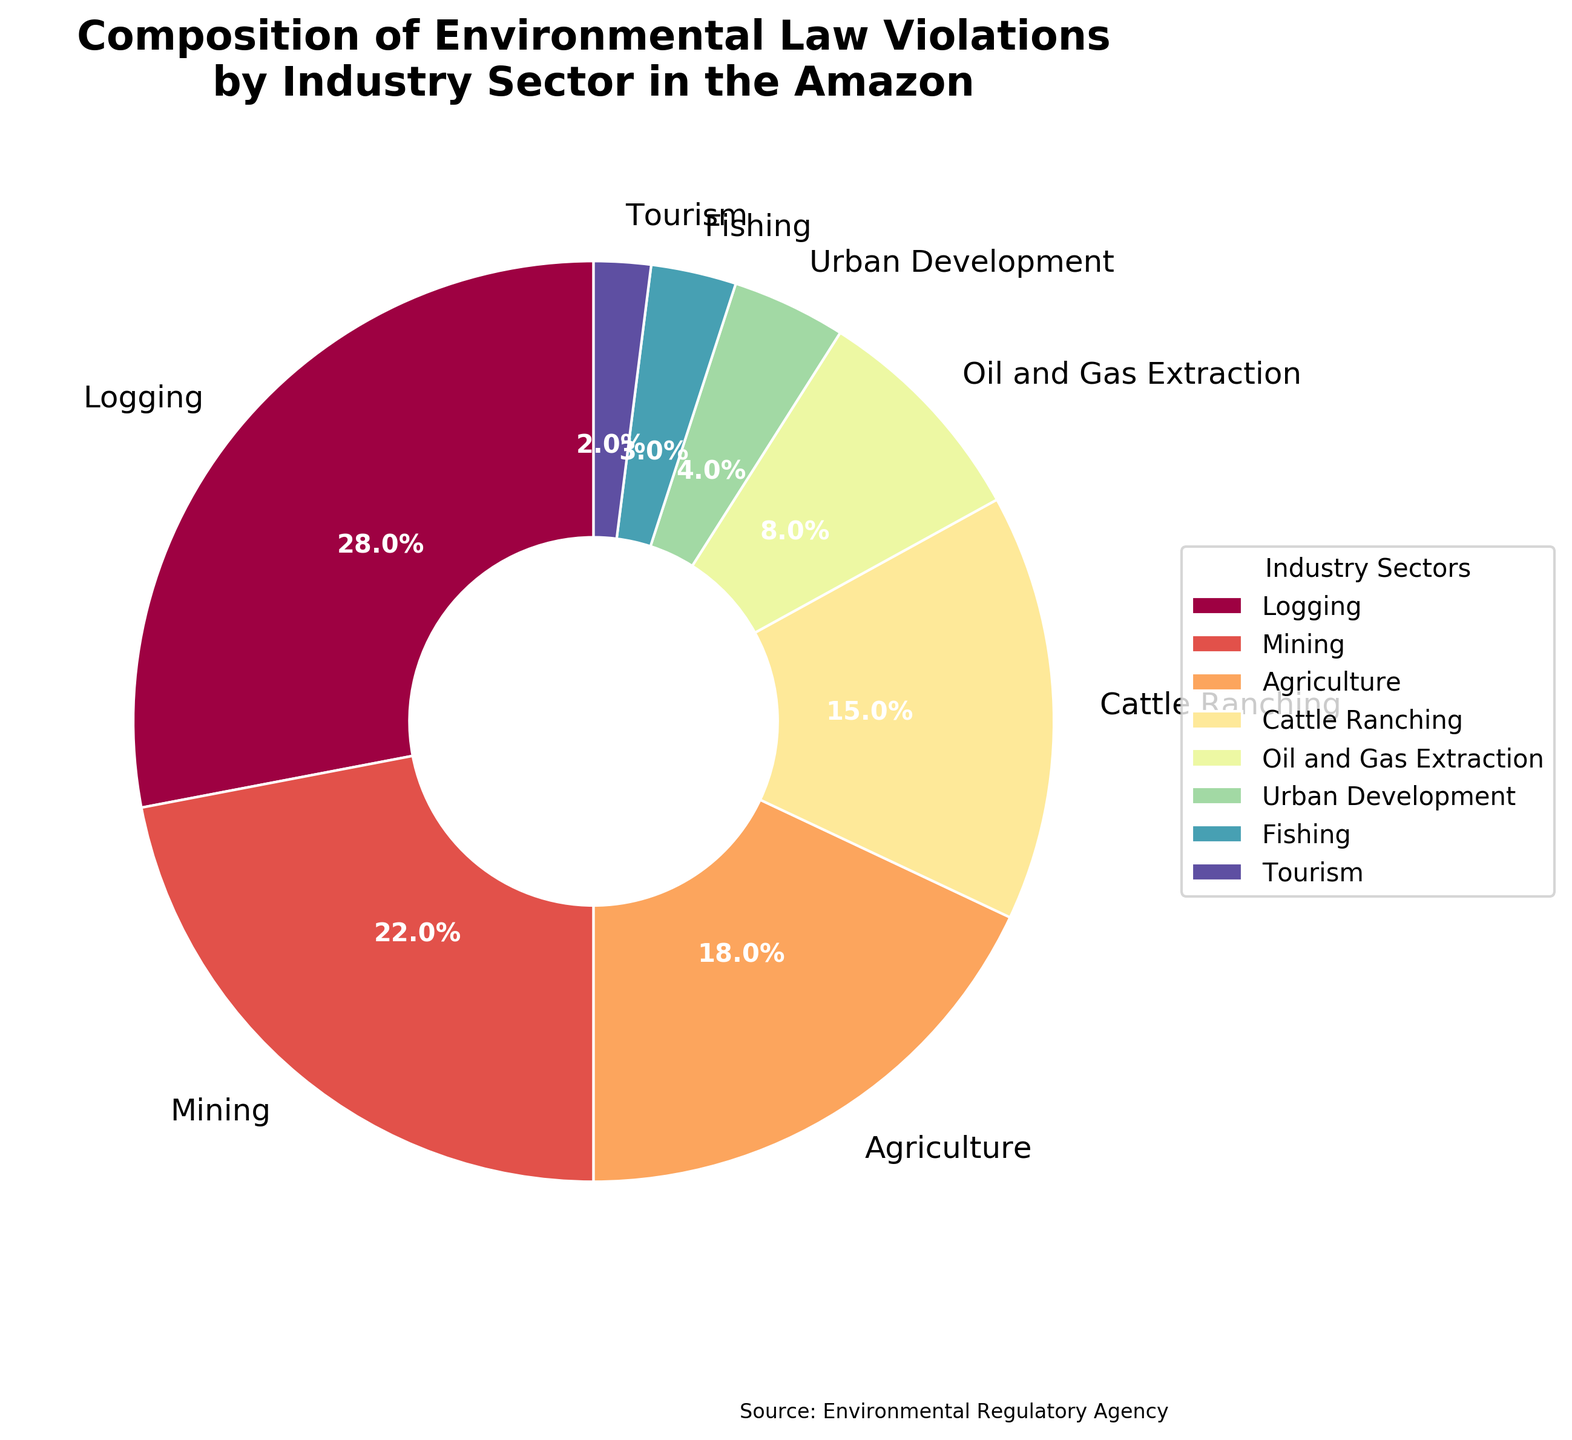Which industry sector has the highest percentage of environmental law violations? The pie chart shows the logging sector with the largest slice, accounting for 28% of the violations, making it the highest.
Answer: Logging Which industry sector has the lowest percentage of environmental law violations? The tourism sector has the smallest slice on the pie chart, indicating it has the lowest percentage at 2%.
Answer: Tourism What is the combined percentage of violations for the top three sectors? To calculate the combined percentage, add the individual percentages of logging (28%), mining (22%), and agriculture (18%): 28 + 22 + 18 = 68%.
Answer: 68% Are there any sectors with an equal percentage of violations? By inspecting the slices of the pie chart and their labels, no two sectors have the same percentage of violations; each value is unique.
Answer: No How much more does logging contribute to violations compared to tourism? Logging accounts for 28% and tourism for 2%. The difference is 28 - 2 = 26%.
Answer: 26% Which color represents the fishing sector? The fishing sector is represented by a specific slice in the pie chart, which, in turn, is colored a distinct hue to differentiate it from other sectors.
Answer: [color as seen on the chart] What percentage difference is there between agriculture and cattle ranching? Agriculture is 18% and cattle ranching is 15%. The difference between them is 18 - 15 = 3%.
Answer: 3% Do the combined violations of urban development and fishing surpass oil and gas extraction? Urban development is 4%, and fishing is 3%. Combined, they make 4 + 3 = 7%. Since oil and gas extraction is 8%, 7% does not surpass 8%.
Answer: No How does the contribution from mining compare to that from cattle ranching? Mining accounts for 22% and cattle ranching 15%. Since 22% is more than 15%, mining contributes more to violations.
Answer: More Which sectors contribute less than 10% to the violations? By inspecting the chart, the sectors with less than 10% are oil and gas extraction (8%), urban development (4%), fishing (3%), and tourism (2%).
Answer: Oil and Gas Extraction, Urban Development, Fishing, Tourism 